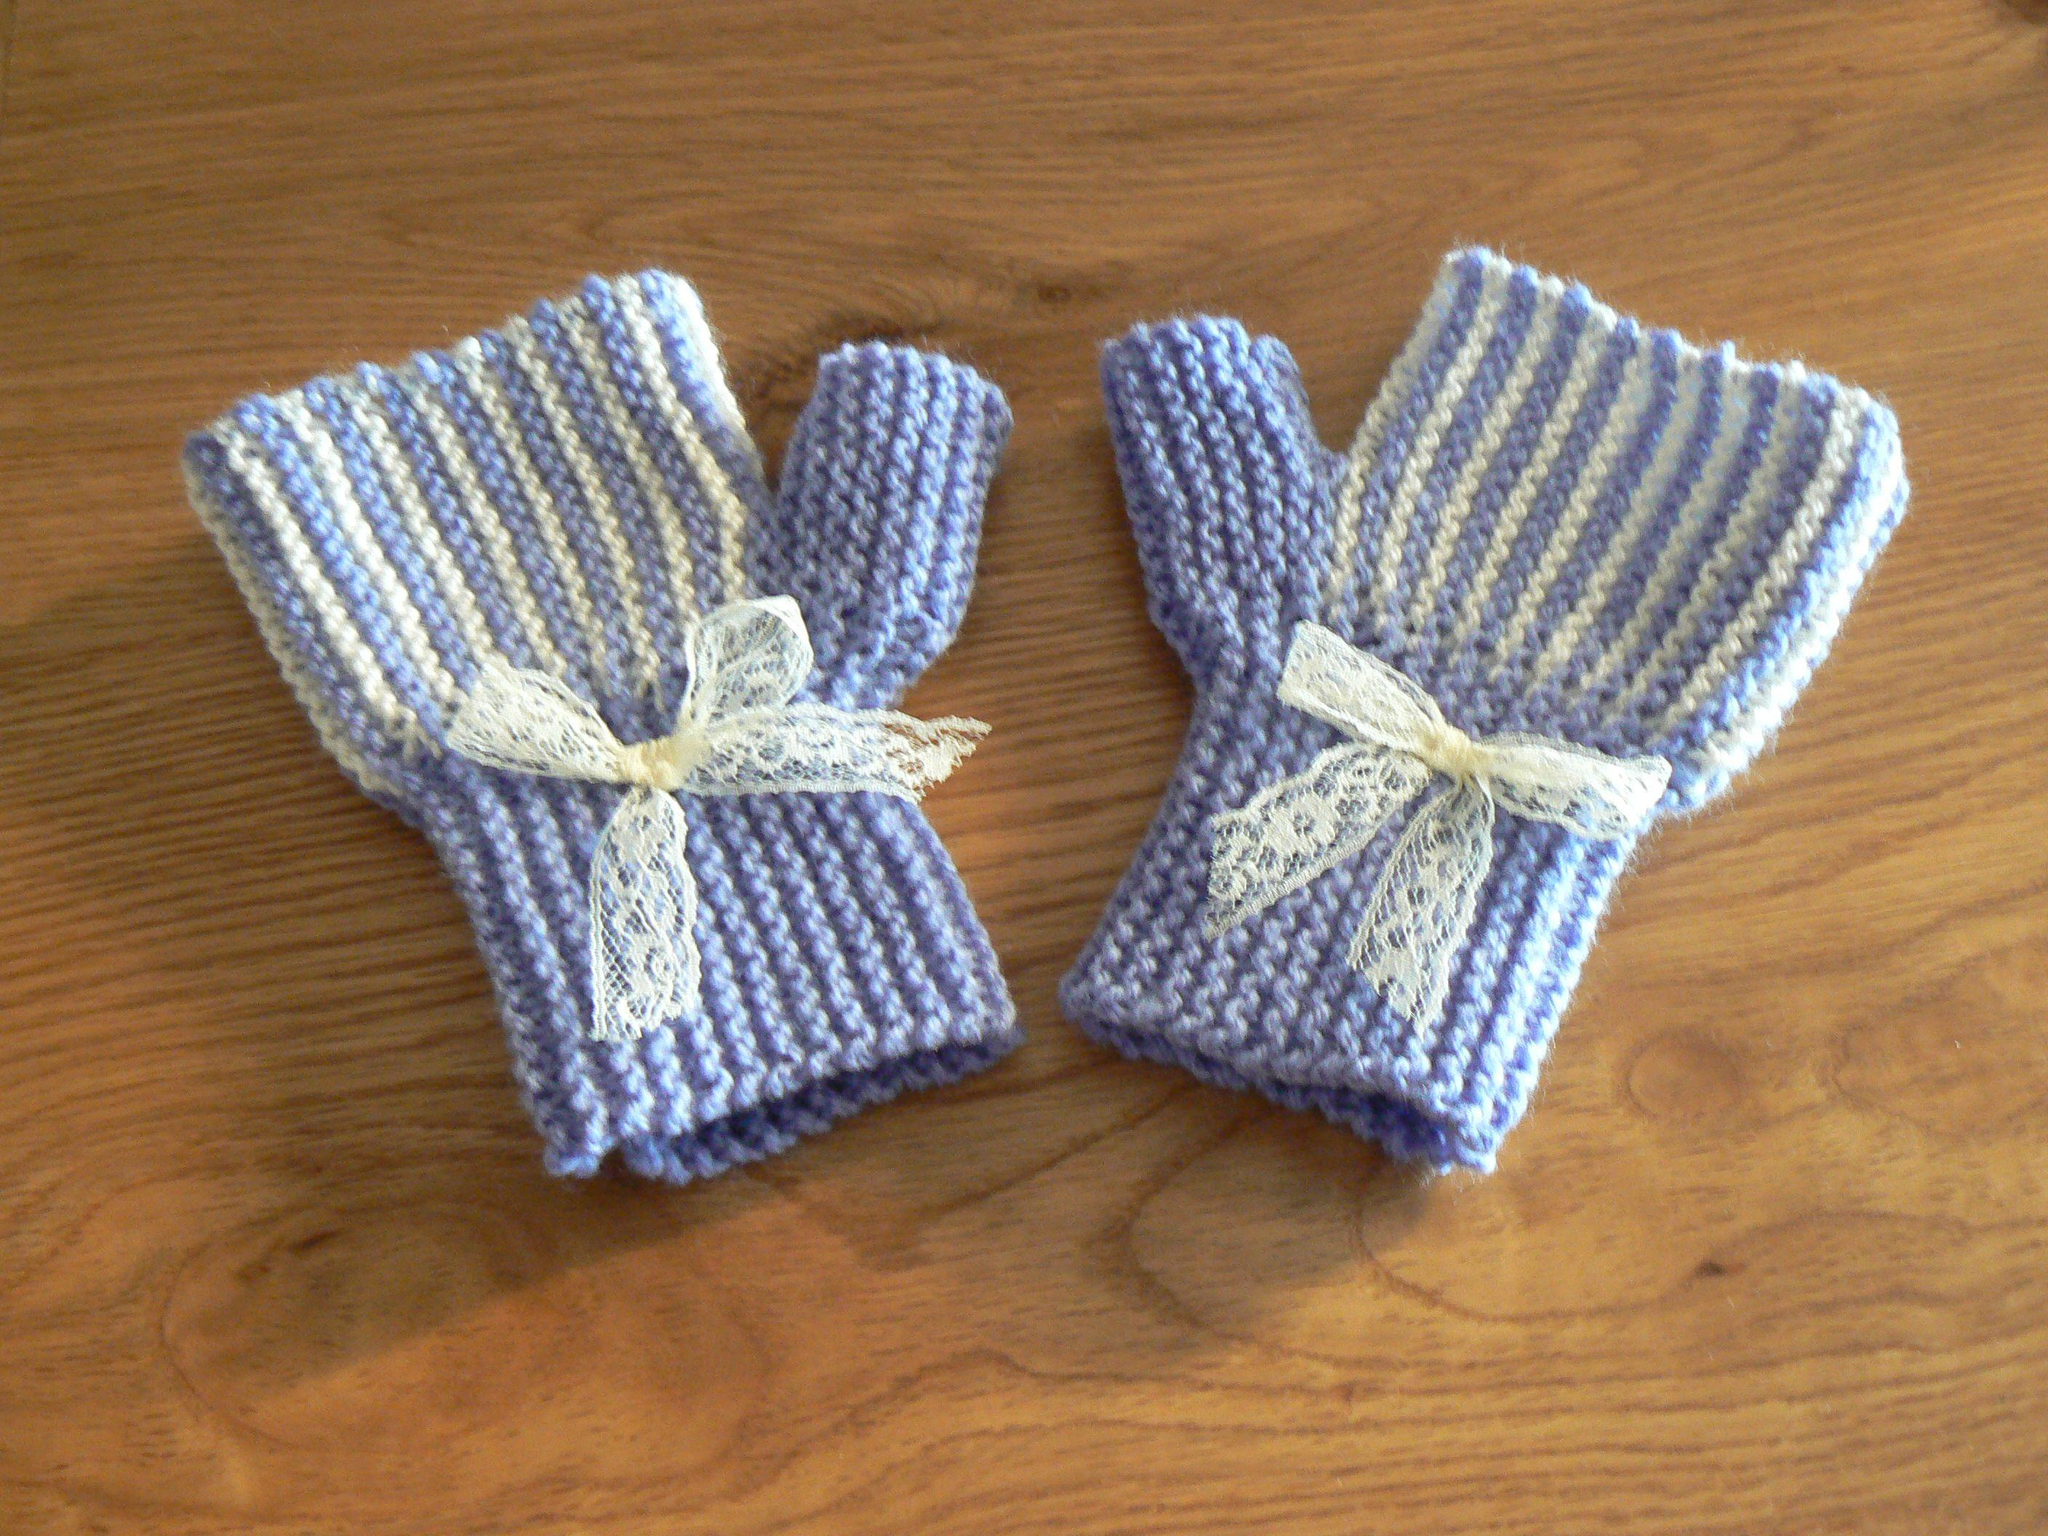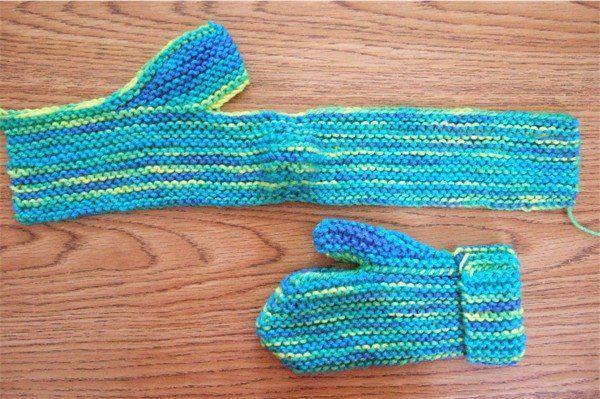The first image is the image on the left, the second image is the image on the right. For the images shown, is this caption "The left and right image contains a total of three gloves." true? Answer yes or no. Yes. 